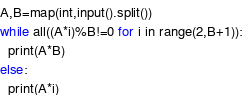<code> <loc_0><loc_0><loc_500><loc_500><_Python_>A,B=map(int,input().split())
while all((A*i)%B!=0 for i in range(2,B+1)):
  print(A*B)
else:
  print(A*i)</code> 